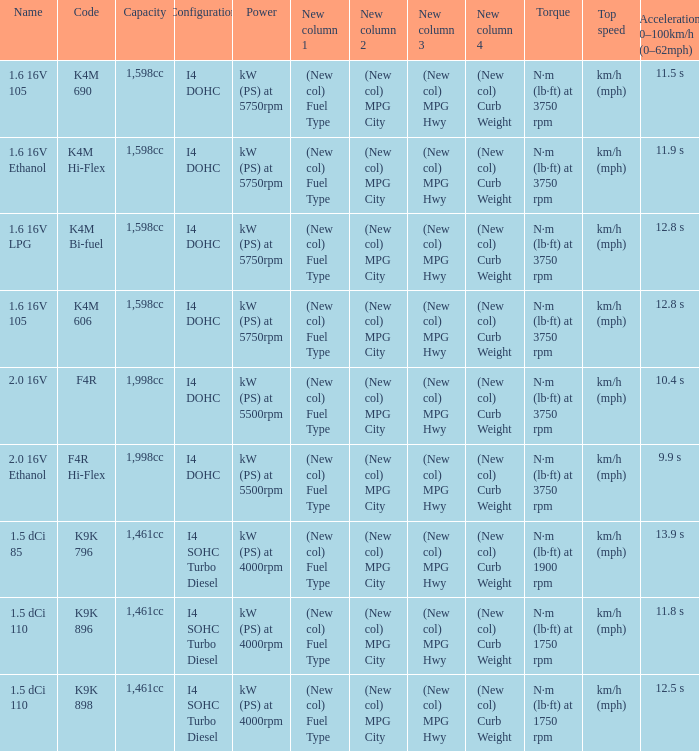What is the code of 1.5 dci 110, which has a capacity of 1,461cc? K9K 896, K9K 898. 